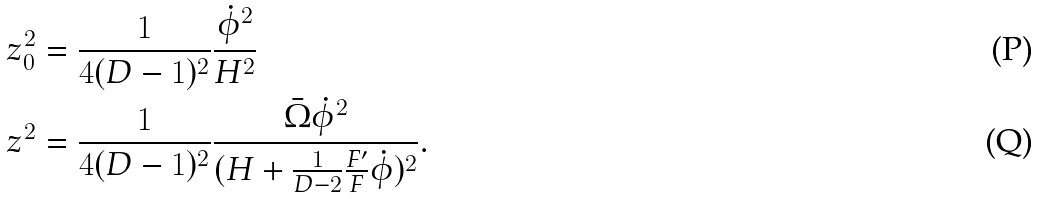<formula> <loc_0><loc_0><loc_500><loc_500>z _ { 0 } ^ { 2 } & = \frac { 1 } { 4 ( D - 1 ) ^ { 2 } } \frac { \dot { \phi } ^ { 2 } } { H ^ { 2 } } \\ z ^ { 2 } & = \frac { 1 } { 4 ( D - 1 ) ^ { 2 } } \frac { \bar { \Omega } \dot { \phi } ^ { 2 } } { ( H + \frac { 1 } { D - 2 } \frac { F ^ { \prime } } { F } \dot { \phi } ) ^ { 2 } } .</formula> 